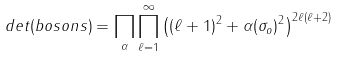<formula> <loc_0><loc_0><loc_500><loc_500>d e t ( b o s o n s ) = \prod _ { \alpha } \prod _ { \ell = 1 } ^ { \infty } \left ( ( \ell + 1 ) ^ { 2 } + \alpha ( \sigma _ { o } ) ^ { 2 } \right ) ^ { 2 \ell ( \ell + 2 ) }</formula> 